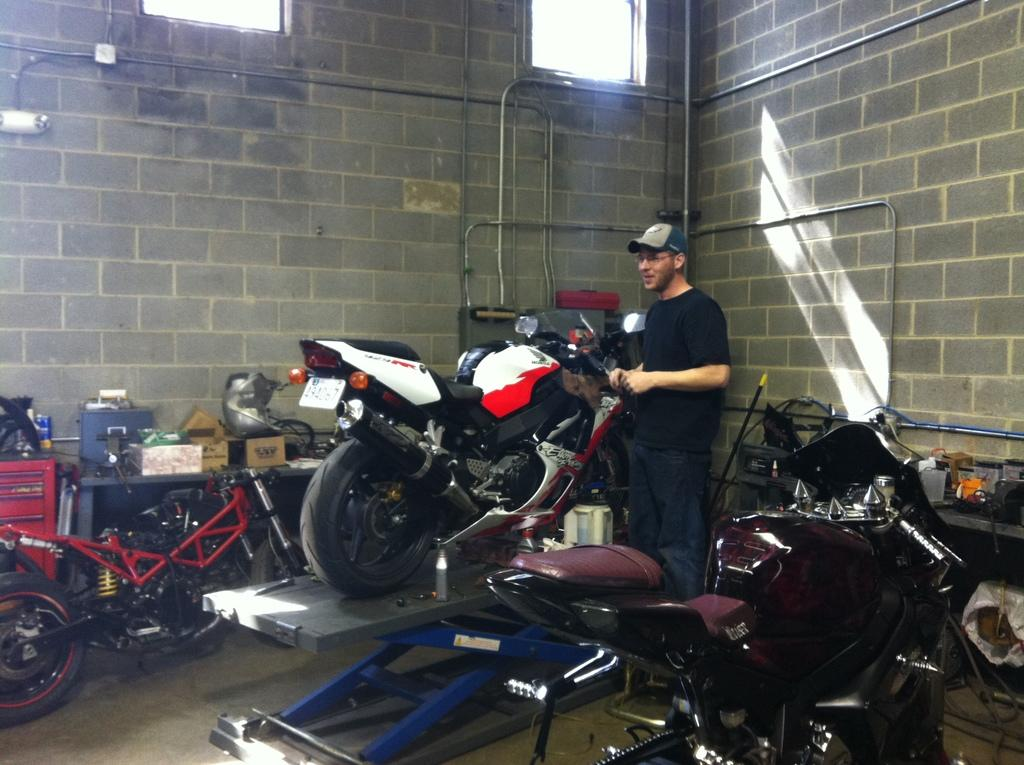What is the person in the image wearing on their face and head? The person in the image is wearing specs and a cap. What can be seen in large numbers in the image? There are many bikes in the image. What is visible in the background of the image? There is a wall with pipes and windows in the background. What is present on a raised surface in the image? There is a platform with boxes and other items in the image. What type of insurance policy does the person in the image have for their toe? There is no mention of a toe or any insurance policy in the image, so we cannot answer this question. 